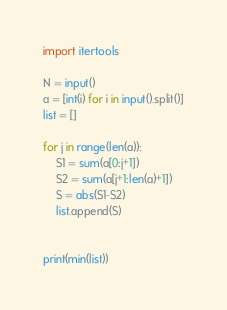Convert code to text. <code><loc_0><loc_0><loc_500><loc_500><_Python_>import itertools

N = input()
a = [int(i) for i in input().split()]
list = []

for j in range(len(a)):
    S1 = sum(a[0:j+1])
    S2 = sum(a[j+1:len(a)+1])
    S = abs(S1-S2)
    list.append(S)


print(min(list))
</code> 